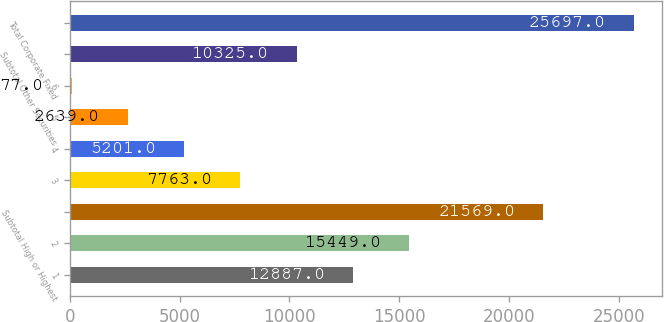<chart> <loc_0><loc_0><loc_500><loc_500><bar_chart><fcel>1<fcel>2<fcel>Subtotal High or Highest<fcel>3<fcel>4<fcel>5<fcel>6<fcel>Subtotal Other Securities<fcel>Total Corporate Fixed<nl><fcel>12887<fcel>15449<fcel>21569<fcel>7763<fcel>5201<fcel>2639<fcel>77<fcel>10325<fcel>25697<nl></chart> 